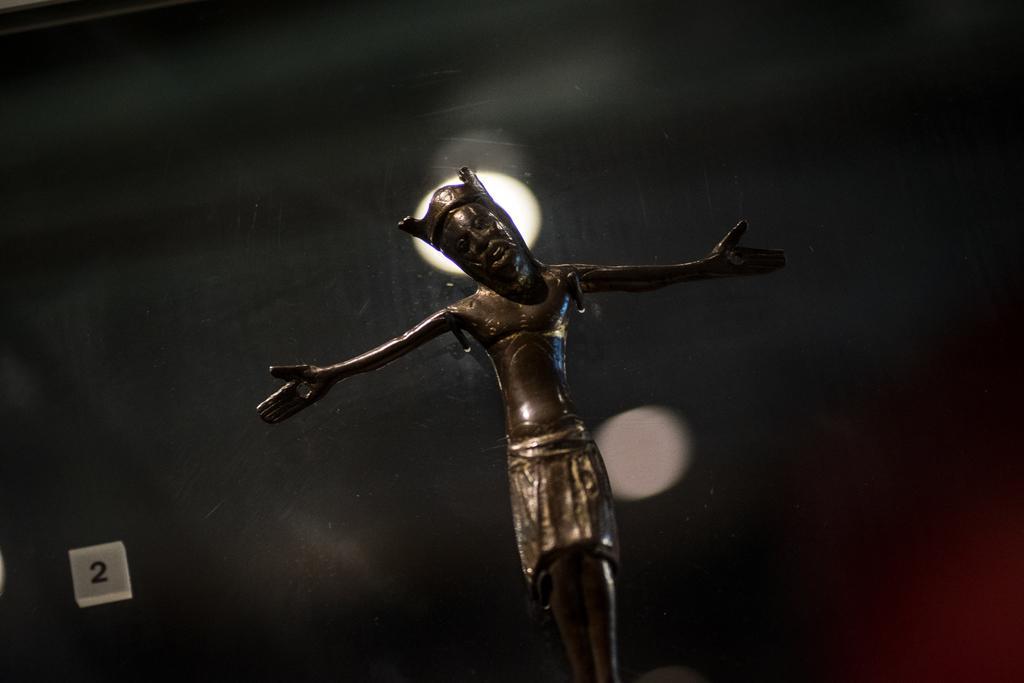In one or two sentences, can you explain what this image depicts? In the image we can see a statue of a person standing, wearing crown. This is a light, the number and the background is dark and blurred. 